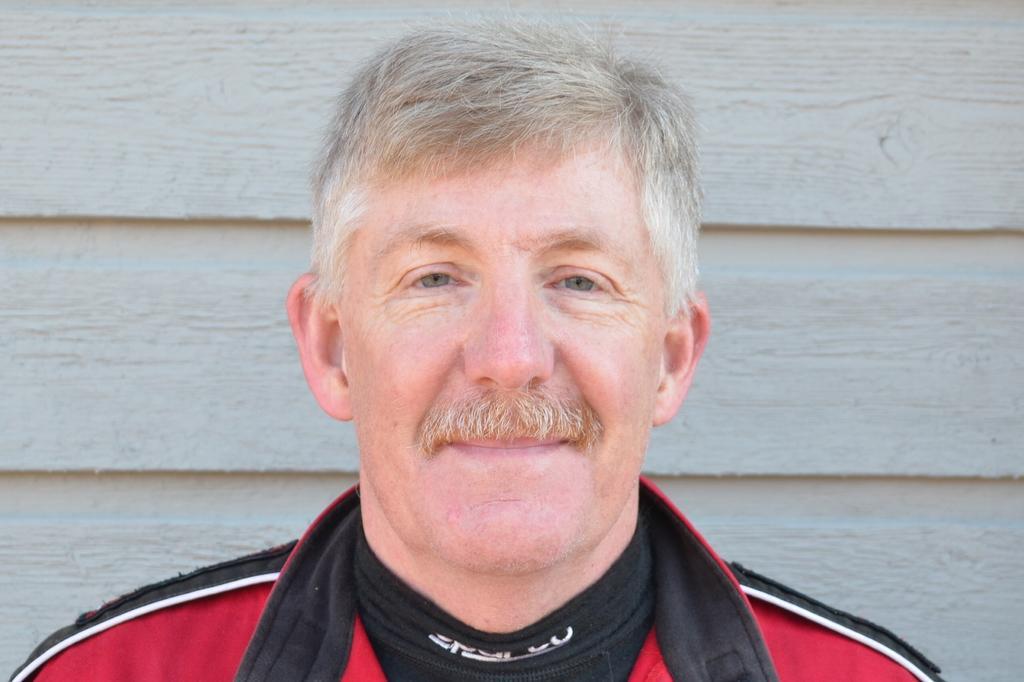Could you give a brief overview of what you see in this image? In this image we can see a person wearing a dress. In the background, we can see the wall. 